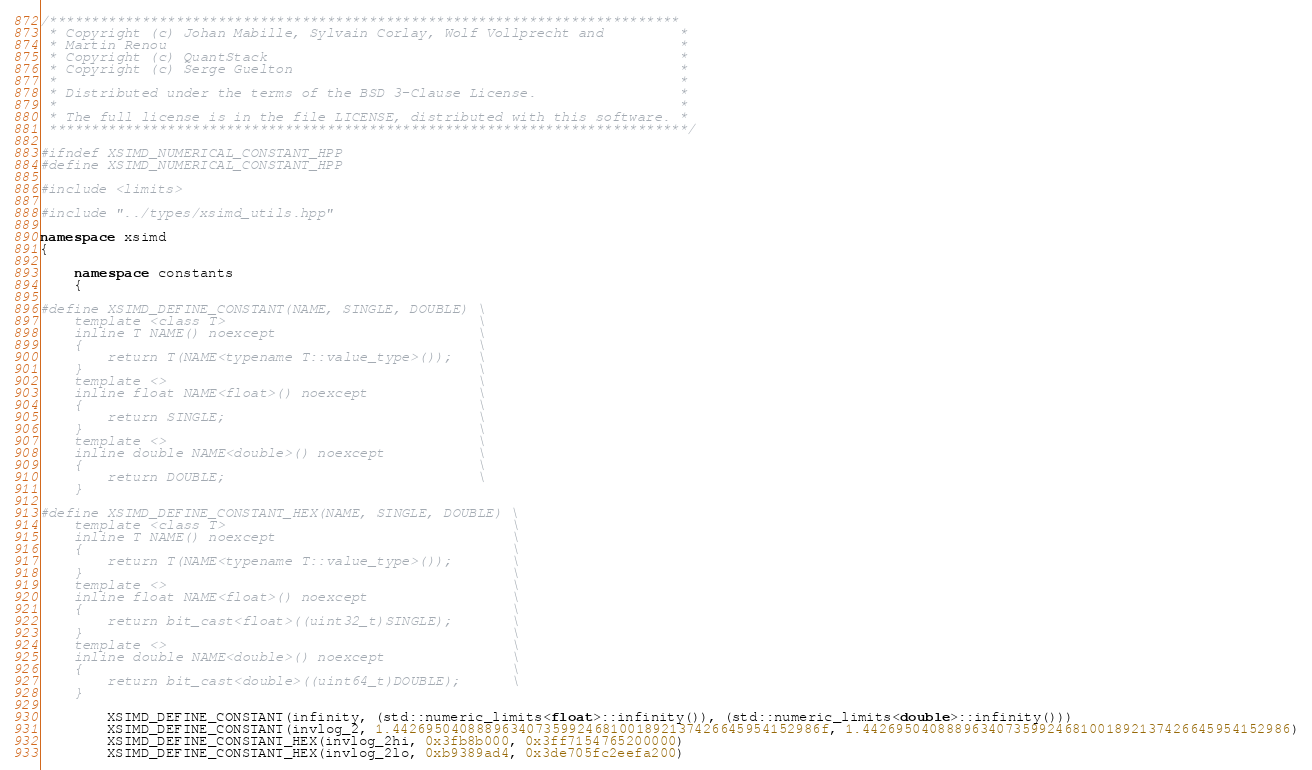<code> <loc_0><loc_0><loc_500><loc_500><_C++_>/***************************************************************************
 * Copyright (c) Johan Mabille, Sylvain Corlay, Wolf Vollprecht and         *
 * Martin Renou                                                             *
 * Copyright (c) QuantStack                                                 *
 * Copyright (c) Serge Guelton                                              *
 *                                                                          *
 * Distributed under the terms of the BSD 3-Clause License.                 *
 *                                                                          *
 * The full license is in the file LICENSE, distributed with this software. *
 ****************************************************************************/

#ifndef XSIMD_NUMERICAL_CONSTANT_HPP
#define XSIMD_NUMERICAL_CONSTANT_HPP

#include <limits>

#include "../types/xsimd_utils.hpp"

namespace xsimd
{

    namespace constants
    {

#define XSIMD_DEFINE_CONSTANT(NAME, SINGLE, DOUBLE) \
    template <class T>                              \
    inline T NAME() noexcept                        \
    {                                               \
        return T(NAME<typename T::value_type>());   \
    }                                               \
    template <>                                     \
    inline float NAME<float>() noexcept             \
    {                                               \
        return SINGLE;                              \
    }                                               \
    template <>                                     \
    inline double NAME<double>() noexcept           \
    {                                               \
        return DOUBLE;                              \
    }

#define XSIMD_DEFINE_CONSTANT_HEX(NAME, SINGLE, DOUBLE) \
    template <class T>                                  \
    inline T NAME() noexcept                            \
    {                                                   \
        return T(NAME<typename T::value_type>());       \
    }                                                   \
    template <>                                         \
    inline float NAME<float>() noexcept                 \
    {                                                   \
        return bit_cast<float>((uint32_t)SINGLE);       \
    }                                                   \
    template <>                                         \
    inline double NAME<double>() noexcept               \
    {                                                   \
        return bit_cast<double>((uint64_t)DOUBLE);      \
    }

        XSIMD_DEFINE_CONSTANT(infinity, (std::numeric_limits<float>::infinity()), (std::numeric_limits<double>::infinity()))
        XSIMD_DEFINE_CONSTANT(invlog_2, 1.442695040888963407359924681001892137426645954152986f, 1.442695040888963407359924681001892137426645954152986)
        XSIMD_DEFINE_CONSTANT_HEX(invlog_2hi, 0x3fb8b000, 0x3ff7154765200000)
        XSIMD_DEFINE_CONSTANT_HEX(invlog_2lo, 0xb9389ad4, 0x3de705fc2eefa200)</code> 